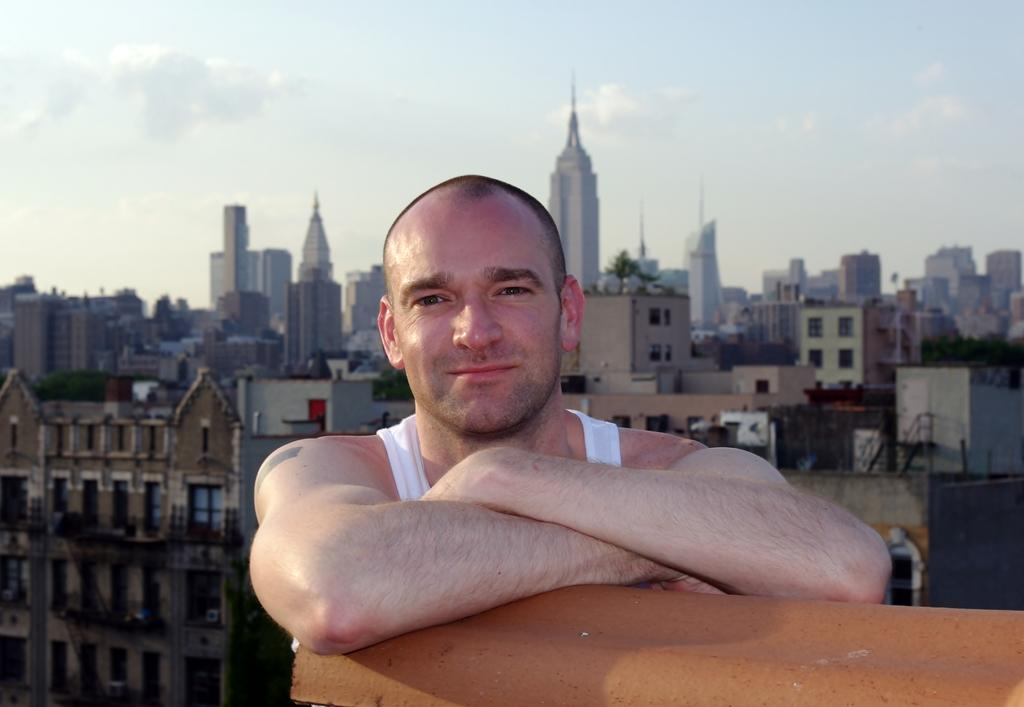Who is present in the image? There is a man in the image. What is the orange object in the image? The orange object in the image is not specified, but it is present. What can be seen in the distance in the image? There are buildings in the background of the image. What is the condition of the sky in the image? The sky is clear and visible in the background of the image. What type of joke is the man telling in the image? There is no indication in the image that the man is telling a joke, so it cannot be determined from the picture. 